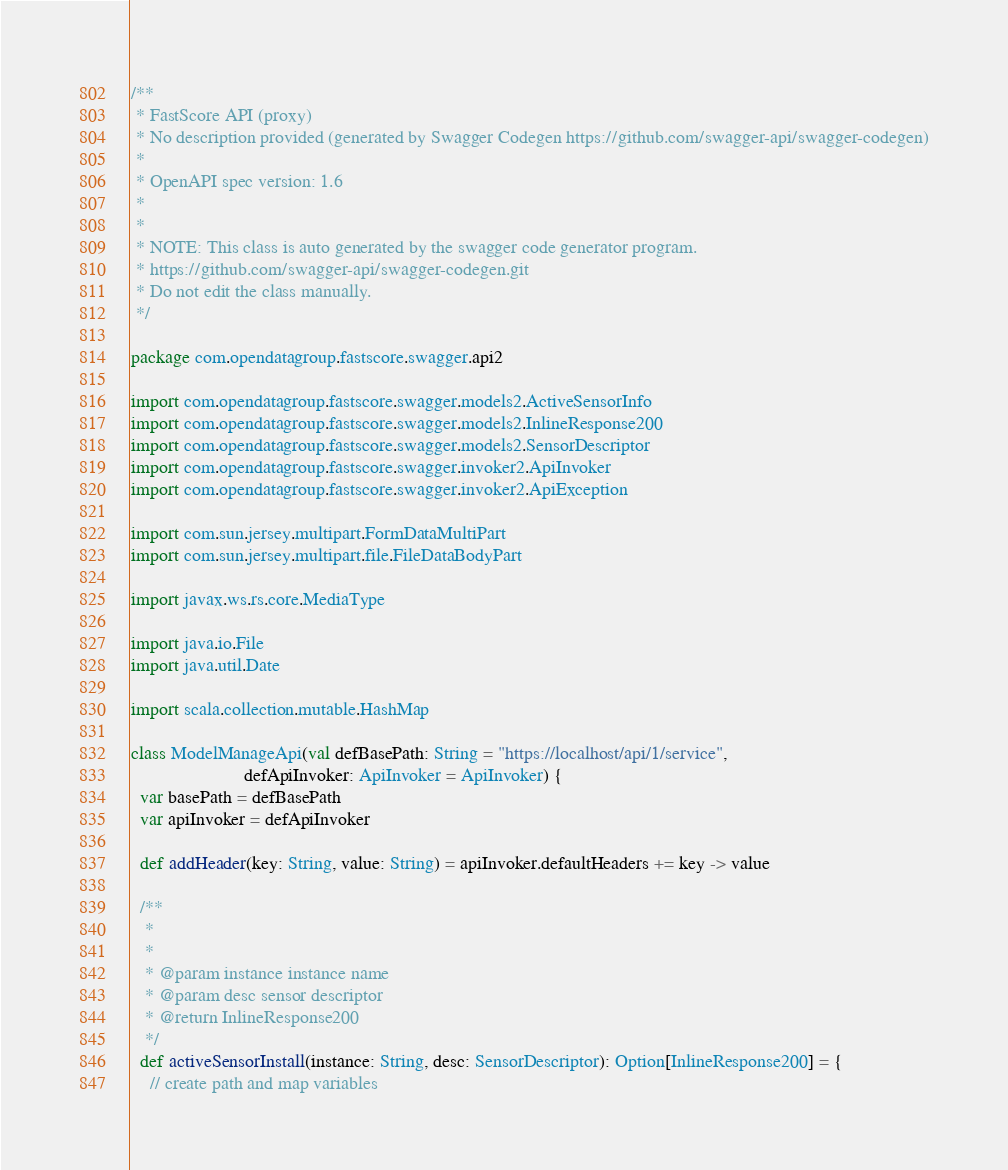<code> <loc_0><loc_0><loc_500><loc_500><_Scala_>/**
 * FastScore API (proxy)
 * No description provided (generated by Swagger Codegen https://github.com/swagger-api/swagger-codegen)
 *
 * OpenAPI spec version: 1.6
 * 
 *
 * NOTE: This class is auto generated by the swagger code generator program.
 * https://github.com/swagger-api/swagger-codegen.git
 * Do not edit the class manually.
 */

package com.opendatagroup.fastscore.swagger.api2

import com.opendatagroup.fastscore.swagger.models2.ActiveSensorInfo
import com.opendatagroup.fastscore.swagger.models2.InlineResponse200
import com.opendatagroup.fastscore.swagger.models2.SensorDescriptor
import com.opendatagroup.fastscore.swagger.invoker2.ApiInvoker
import com.opendatagroup.fastscore.swagger.invoker2.ApiException

import com.sun.jersey.multipart.FormDataMultiPart
import com.sun.jersey.multipart.file.FileDataBodyPart

import javax.ws.rs.core.MediaType

import java.io.File
import java.util.Date

import scala.collection.mutable.HashMap

class ModelManageApi(val defBasePath: String = "https://localhost/api/1/service",
                        defApiInvoker: ApiInvoker = ApiInvoker) {
  var basePath = defBasePath
  var apiInvoker = defApiInvoker

  def addHeader(key: String, value: String) = apiInvoker.defaultHeaders += key -> value 

  /**
   * 
   * 
   * @param instance instance name 
   * @param desc sensor descriptor 
   * @return InlineResponse200
   */
  def activeSensorInstall(instance: String, desc: SensorDescriptor): Option[InlineResponse200] = {
    // create path and map variables</code> 